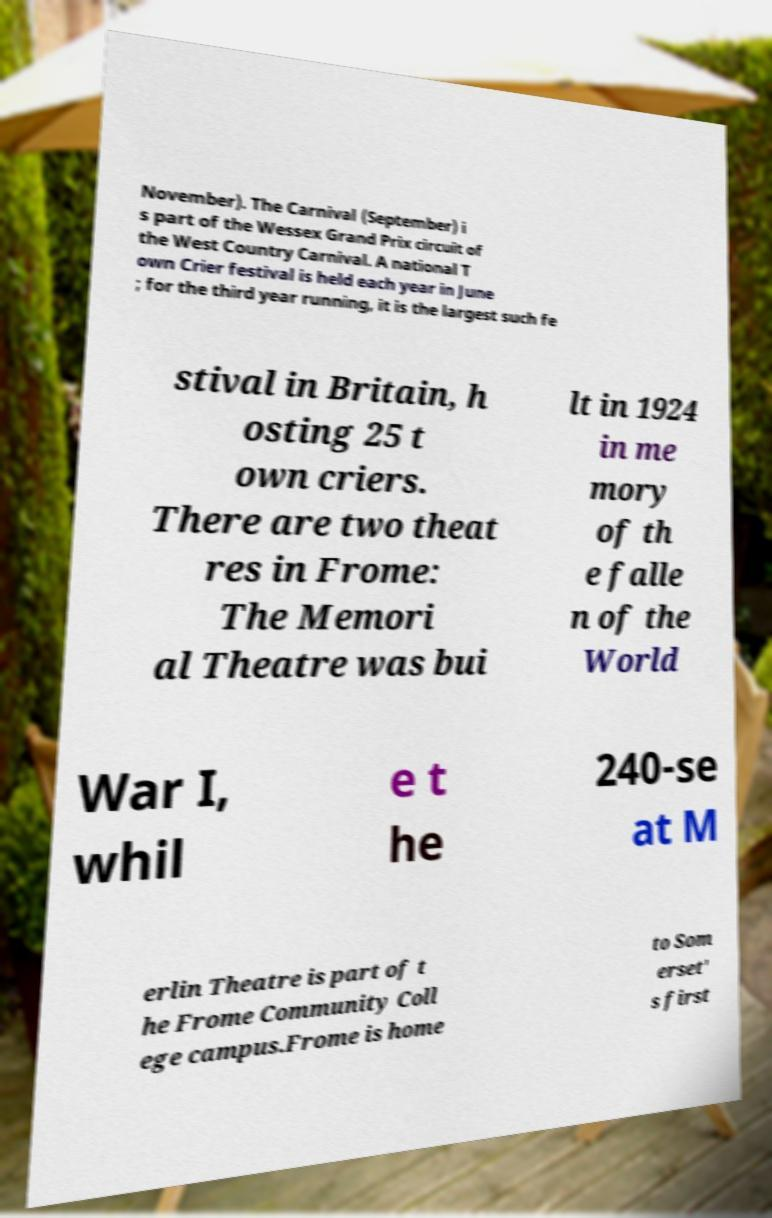For documentation purposes, I need the text within this image transcribed. Could you provide that? November). The Carnival (September) i s part of the Wessex Grand Prix circuit of the West Country Carnival. A national T own Crier festival is held each year in June ; for the third year running, it is the largest such fe stival in Britain, h osting 25 t own criers. There are two theat res in Frome: The Memori al Theatre was bui lt in 1924 in me mory of th e falle n of the World War I, whil e t he 240-se at M erlin Theatre is part of t he Frome Community Coll ege campus.Frome is home to Som erset' s first 